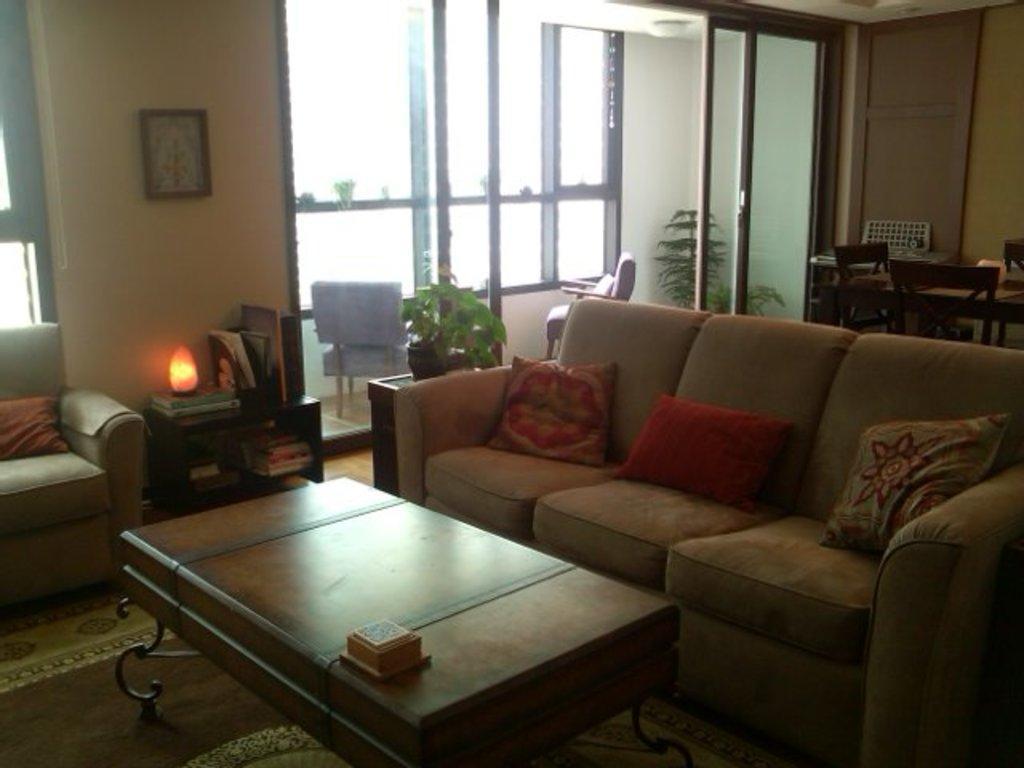Could you give a brief overview of what you see in this image? These are the sofas and there are pillows. This is table and there are chairs. Here we can see planets and this is glass. In the background there is a wall and this is frame. This is lamp and there is a door. And this is floor. 